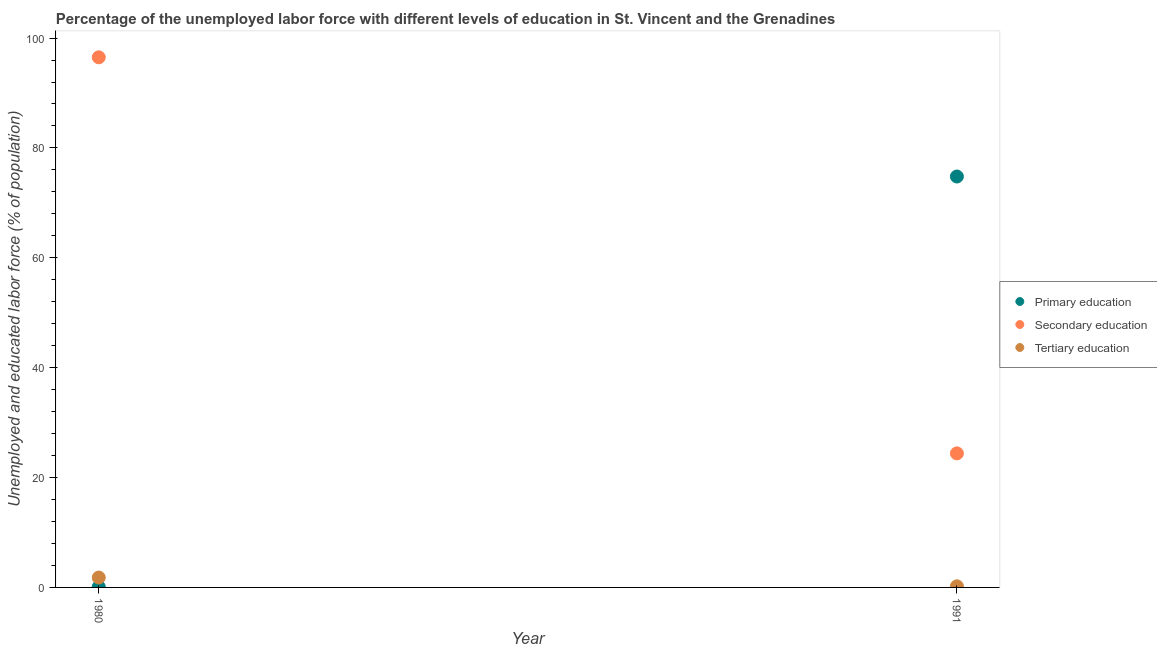What is the percentage of labor force who received tertiary education in 1991?
Your response must be concise. 0.2. Across all years, what is the maximum percentage of labor force who received tertiary education?
Offer a very short reply. 1.8. Across all years, what is the minimum percentage of labor force who received tertiary education?
Your answer should be compact. 0.2. What is the total percentage of labor force who received primary education in the graph?
Offer a terse response. 74.9. What is the difference between the percentage of labor force who received secondary education in 1980 and that in 1991?
Make the answer very short. 72.1. What is the difference between the percentage of labor force who received primary education in 1980 and the percentage of labor force who received tertiary education in 1991?
Give a very brief answer. -0.1. What is the average percentage of labor force who received secondary education per year?
Your answer should be compact. 60.45. In the year 1980, what is the difference between the percentage of labor force who received tertiary education and percentage of labor force who received primary education?
Offer a terse response. 1.7. What is the ratio of the percentage of labor force who received tertiary education in 1980 to that in 1991?
Provide a short and direct response. 9. Is the percentage of labor force who received secondary education in 1980 less than that in 1991?
Give a very brief answer. No. In how many years, is the percentage of labor force who received secondary education greater than the average percentage of labor force who received secondary education taken over all years?
Offer a very short reply. 1. Is the percentage of labor force who received secondary education strictly greater than the percentage of labor force who received tertiary education over the years?
Offer a very short reply. Yes. How many dotlines are there?
Keep it short and to the point. 3. How many years are there in the graph?
Offer a very short reply. 2. What is the difference between two consecutive major ticks on the Y-axis?
Give a very brief answer. 20. Are the values on the major ticks of Y-axis written in scientific E-notation?
Make the answer very short. No. Does the graph contain any zero values?
Give a very brief answer. No. How are the legend labels stacked?
Your answer should be compact. Vertical. What is the title of the graph?
Provide a succinct answer. Percentage of the unemployed labor force with different levels of education in St. Vincent and the Grenadines. Does "Infant(male)" appear as one of the legend labels in the graph?
Make the answer very short. No. What is the label or title of the Y-axis?
Keep it short and to the point. Unemployed and educated labor force (% of population). What is the Unemployed and educated labor force (% of population) in Primary education in 1980?
Offer a very short reply. 0.1. What is the Unemployed and educated labor force (% of population) of Secondary education in 1980?
Make the answer very short. 96.5. What is the Unemployed and educated labor force (% of population) in Tertiary education in 1980?
Provide a succinct answer. 1.8. What is the Unemployed and educated labor force (% of population) in Primary education in 1991?
Your response must be concise. 74.8. What is the Unemployed and educated labor force (% of population) in Secondary education in 1991?
Ensure brevity in your answer.  24.4. What is the Unemployed and educated labor force (% of population) in Tertiary education in 1991?
Ensure brevity in your answer.  0.2. Across all years, what is the maximum Unemployed and educated labor force (% of population) of Primary education?
Your response must be concise. 74.8. Across all years, what is the maximum Unemployed and educated labor force (% of population) in Secondary education?
Offer a very short reply. 96.5. Across all years, what is the maximum Unemployed and educated labor force (% of population) of Tertiary education?
Make the answer very short. 1.8. Across all years, what is the minimum Unemployed and educated labor force (% of population) in Primary education?
Ensure brevity in your answer.  0.1. Across all years, what is the minimum Unemployed and educated labor force (% of population) of Secondary education?
Your answer should be compact. 24.4. Across all years, what is the minimum Unemployed and educated labor force (% of population) of Tertiary education?
Ensure brevity in your answer.  0.2. What is the total Unemployed and educated labor force (% of population) of Primary education in the graph?
Keep it short and to the point. 74.9. What is the total Unemployed and educated labor force (% of population) in Secondary education in the graph?
Provide a short and direct response. 120.9. What is the total Unemployed and educated labor force (% of population) in Tertiary education in the graph?
Provide a short and direct response. 2. What is the difference between the Unemployed and educated labor force (% of population) of Primary education in 1980 and that in 1991?
Your answer should be very brief. -74.7. What is the difference between the Unemployed and educated labor force (% of population) of Secondary education in 1980 and that in 1991?
Ensure brevity in your answer.  72.1. What is the difference between the Unemployed and educated labor force (% of population) in Primary education in 1980 and the Unemployed and educated labor force (% of population) in Secondary education in 1991?
Make the answer very short. -24.3. What is the difference between the Unemployed and educated labor force (% of population) of Primary education in 1980 and the Unemployed and educated labor force (% of population) of Tertiary education in 1991?
Give a very brief answer. -0.1. What is the difference between the Unemployed and educated labor force (% of population) in Secondary education in 1980 and the Unemployed and educated labor force (% of population) in Tertiary education in 1991?
Give a very brief answer. 96.3. What is the average Unemployed and educated labor force (% of population) in Primary education per year?
Your response must be concise. 37.45. What is the average Unemployed and educated labor force (% of population) of Secondary education per year?
Offer a very short reply. 60.45. In the year 1980, what is the difference between the Unemployed and educated labor force (% of population) in Primary education and Unemployed and educated labor force (% of population) in Secondary education?
Give a very brief answer. -96.4. In the year 1980, what is the difference between the Unemployed and educated labor force (% of population) of Primary education and Unemployed and educated labor force (% of population) of Tertiary education?
Provide a succinct answer. -1.7. In the year 1980, what is the difference between the Unemployed and educated labor force (% of population) of Secondary education and Unemployed and educated labor force (% of population) of Tertiary education?
Your answer should be compact. 94.7. In the year 1991, what is the difference between the Unemployed and educated labor force (% of population) of Primary education and Unemployed and educated labor force (% of population) of Secondary education?
Your answer should be very brief. 50.4. In the year 1991, what is the difference between the Unemployed and educated labor force (% of population) in Primary education and Unemployed and educated labor force (% of population) in Tertiary education?
Offer a very short reply. 74.6. In the year 1991, what is the difference between the Unemployed and educated labor force (% of population) of Secondary education and Unemployed and educated labor force (% of population) of Tertiary education?
Offer a terse response. 24.2. What is the ratio of the Unemployed and educated labor force (% of population) in Primary education in 1980 to that in 1991?
Your answer should be compact. 0. What is the ratio of the Unemployed and educated labor force (% of population) in Secondary education in 1980 to that in 1991?
Provide a short and direct response. 3.95. What is the ratio of the Unemployed and educated labor force (% of population) in Tertiary education in 1980 to that in 1991?
Offer a very short reply. 9. What is the difference between the highest and the second highest Unemployed and educated labor force (% of population) of Primary education?
Your answer should be very brief. 74.7. What is the difference between the highest and the second highest Unemployed and educated labor force (% of population) of Secondary education?
Your answer should be very brief. 72.1. What is the difference between the highest and the second highest Unemployed and educated labor force (% of population) of Tertiary education?
Provide a succinct answer. 1.6. What is the difference between the highest and the lowest Unemployed and educated labor force (% of population) of Primary education?
Your response must be concise. 74.7. What is the difference between the highest and the lowest Unemployed and educated labor force (% of population) of Secondary education?
Offer a terse response. 72.1. What is the difference between the highest and the lowest Unemployed and educated labor force (% of population) of Tertiary education?
Ensure brevity in your answer.  1.6. 